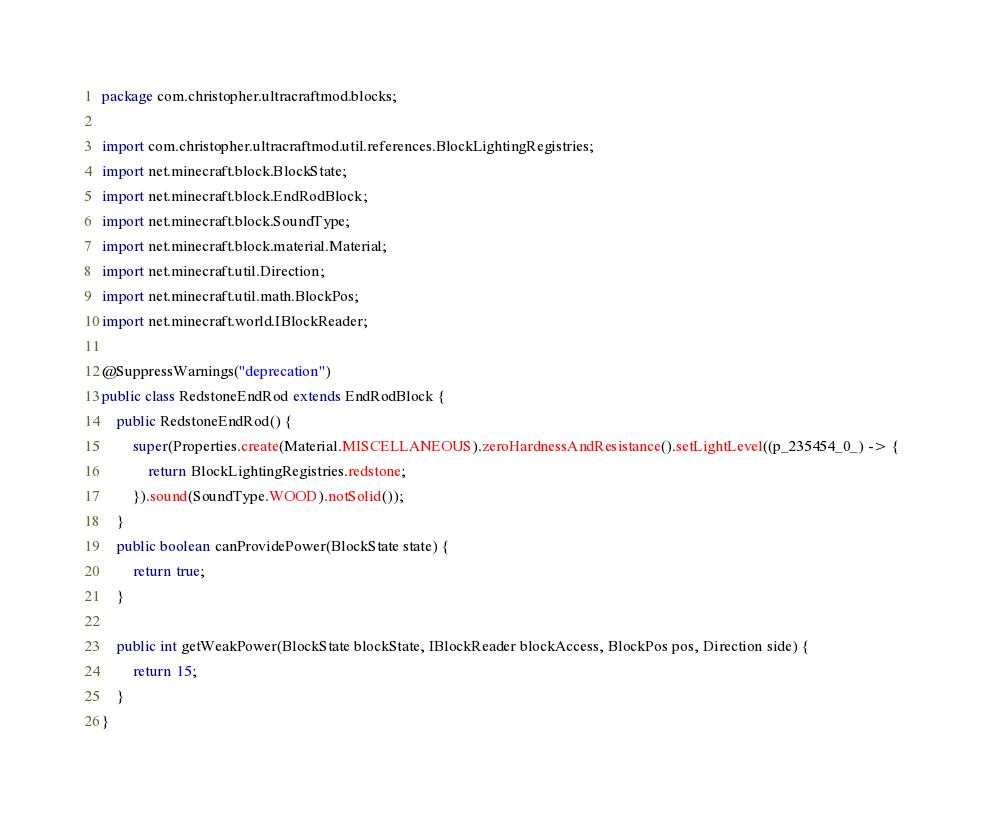<code> <loc_0><loc_0><loc_500><loc_500><_Java_>package com.christopher.ultracraftmod.blocks;

import com.christopher.ultracraftmod.util.references.BlockLightingRegistries;
import net.minecraft.block.BlockState;
import net.minecraft.block.EndRodBlock;
import net.minecraft.block.SoundType;
import net.minecraft.block.material.Material;
import net.minecraft.util.Direction;
import net.minecraft.util.math.BlockPos;
import net.minecraft.world.IBlockReader;

@SuppressWarnings("deprecation")
public class RedstoneEndRod extends EndRodBlock {
    public RedstoneEndRod() {
        super(Properties.create(Material.MISCELLANEOUS).zeroHardnessAndResistance().setLightLevel((p_235454_0_) -> {
            return BlockLightingRegistries.redstone;
        }).sound(SoundType.WOOD).notSolid());
    }
    public boolean canProvidePower(BlockState state) {
        return true;
    }

    public int getWeakPower(BlockState blockState, IBlockReader blockAccess, BlockPos pos, Direction side) {
        return 15;
    }
}
</code> 